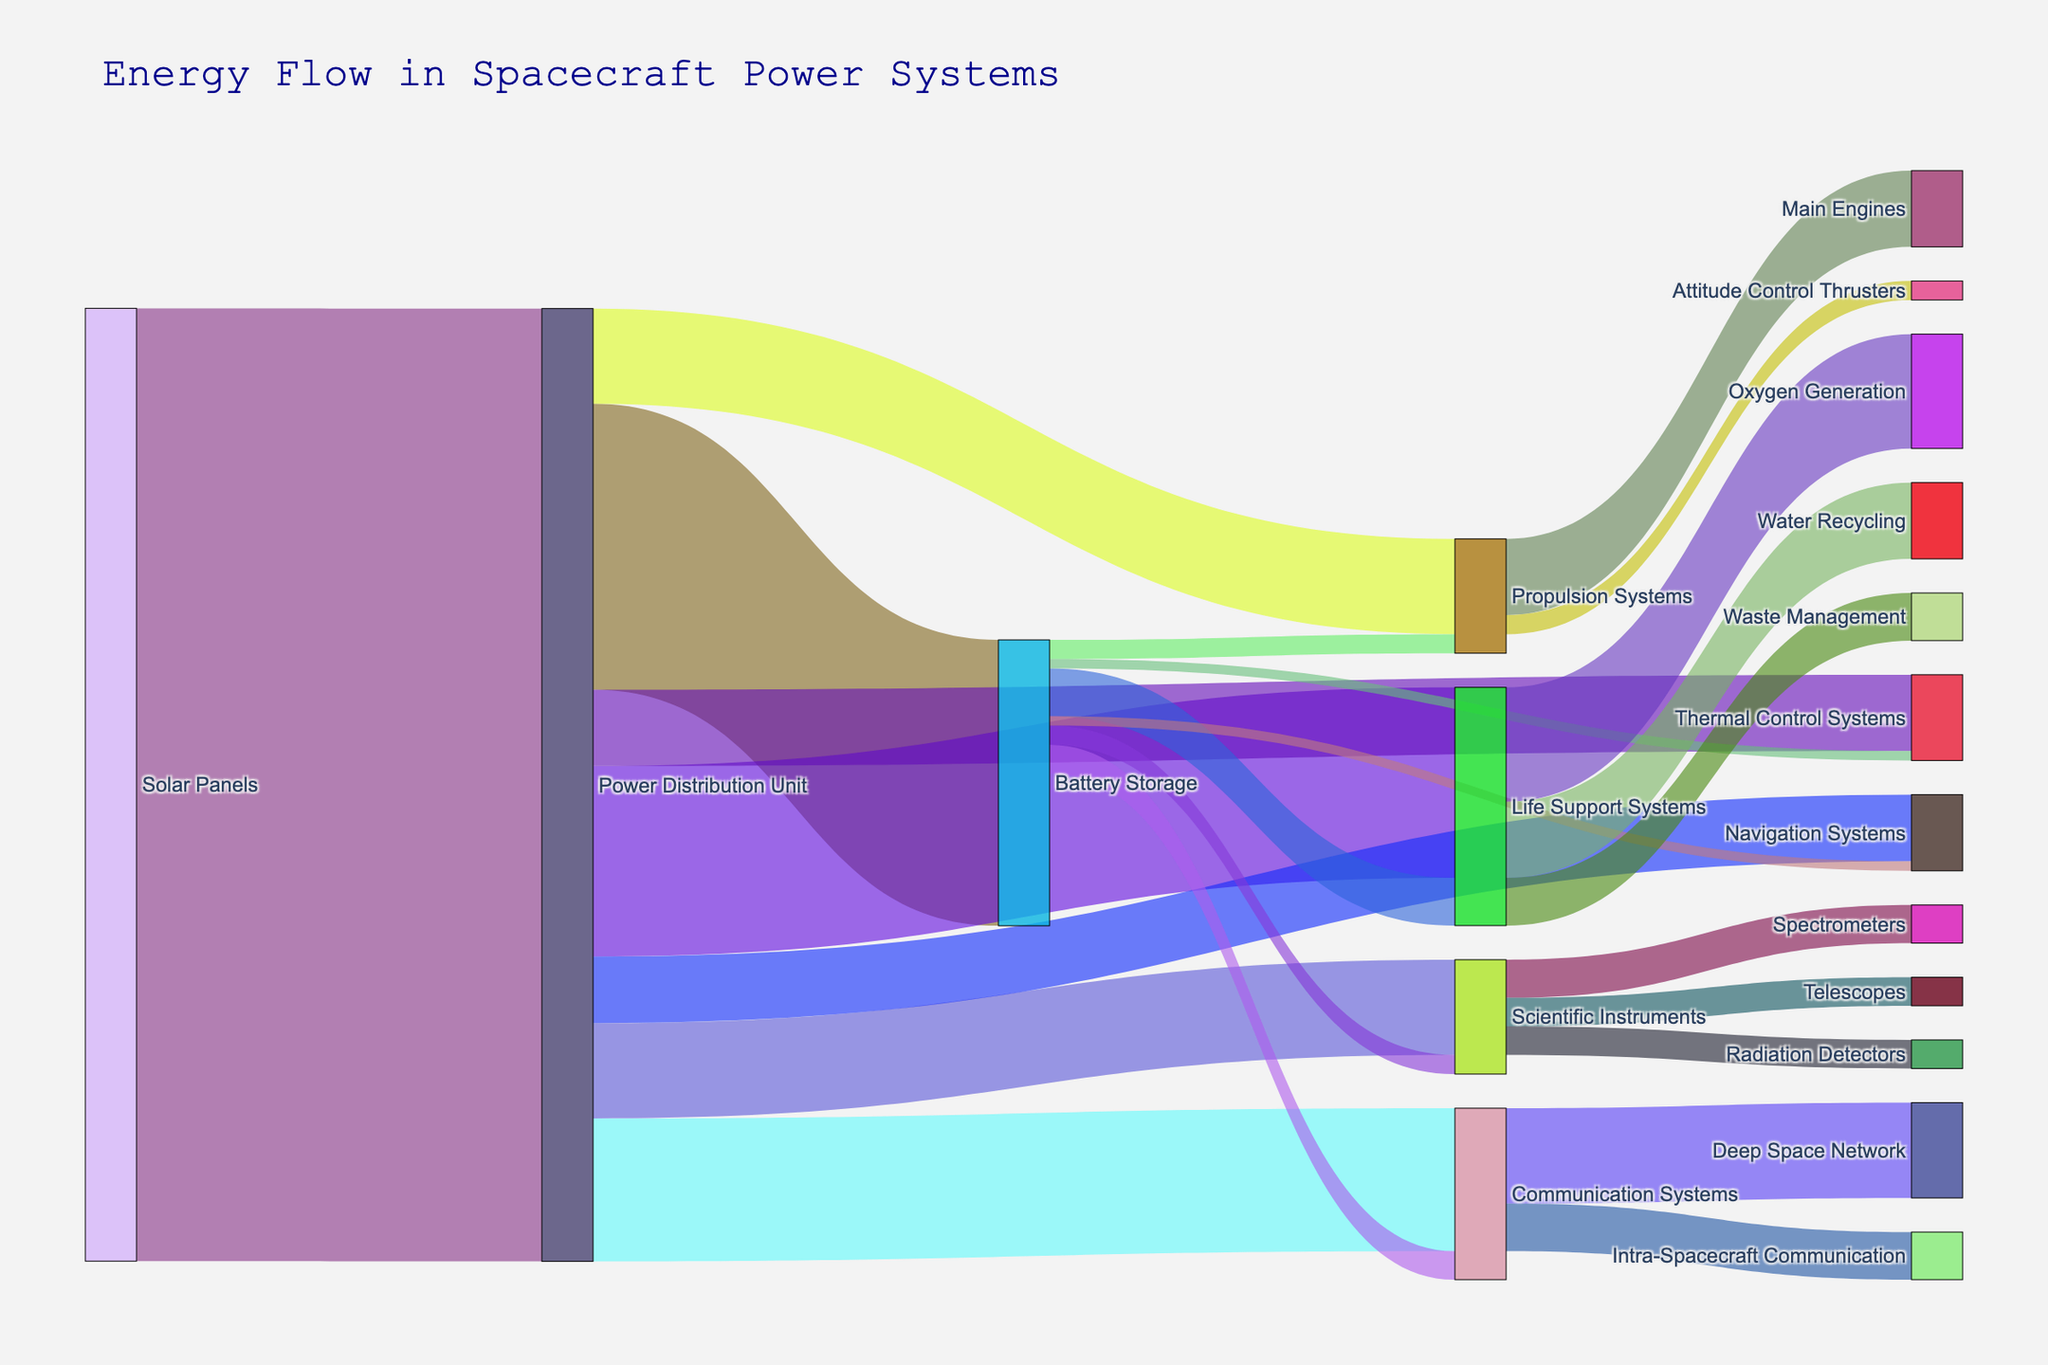What is the total energy coming from the Solar Panels? The starting point of the energy flow in the spacecraft's power system is the Solar Panels, which supply energy to the Power Distribution Unit. In the diagram, the value flowing from the Solar Panels to the Power Distribution Unit is indicated as 1000.
Answer: 1000 Which onboard system receives the most energy from the Power Distribution Unit? Observing the flow from the Power Distribution Unit to different onboard systems, Life Support Systems receive 200 units, which is the highest among all other target systems such as Communication Systems (150), Propulsion Systems (100), etc.
Answer: Life Support Systems How much total energy does the Battery Storage unit supply to onboard systems? Adding up the energy values supplied by the Battery Storage to all systems: Life Support Systems (50) + Communication Systems (30) + Propulsion Systems (20) + Scientific Instruments (20) + Thermal Control Systems (10) + Navigation Systems (10) amounts to a total value of 140.
Answer: 140 What is the combined energy provided to the Life Support Systems from the Power Distribution Unit and Battery Storage? The Power Distribution Unit supplies 200 units to the Life Support Systems and the Battery Storage adds another 50 units. Summing these values (200 + 50) gives a total energy supply of 250 units.
Answer: 250 Which system has the least energy coming directly from the Power Distribution Unit? Reviewing the specific values shown in the Sankey diagram, we see that the Navigation Systems receive the lowest energy of 70 units from the Power Distribution Unit.
Answer: Navigation Systems Is more energy allocated to the Scientific Instruments or the Propulsion Systems from the Battery Storage? The Battery Storage supplies 20 units to both Scientific Instruments and Propulsion Systems, meaning both receive the same energy.
Answer: Equal What percentage of the Power Distribution Unit's output goes to the Life Support Systems? The Power Distribution Unit supplies a total of 1000 units. Out of these, 200 units go to the Life Support Systems. The percentage can be calculated as (200 / 1000) * 100 = 20%.
Answer: 20% How much energy does the Oxygen Generation system receive? According to the data, the Life Support Systems distribute energy further to Oxygen Generation (120), Water Recycling (80), and Waste Management (50). Therefore, Oxygen Generation receives 120 units.
Answer: 120 Compare the energy received by Main Engines and Attitude Control Thrusters within the Propulsion Systems. The Main Engines receive 80 units, while the Attitude Control Thrusters receive 20 units, based on the energy flow from Propulsion Systems. Hence, Main Engines get significantly more energy than the Attitude Control Thrusters.
Answer: Main Engines get more Which Communication Systems sub-component receives more energy: Deep Space Network or Intra-Spacecraft Communication? Observing the division of energy within the Communication Systems: Deep Space Network receives 100 units and Intra-Spacecraft Communication receives 50 units. Deep Space Network receives more energy.
Answer: Deep Space Network 